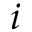<formula> <loc_0><loc_0><loc_500><loc_500>i</formula> 